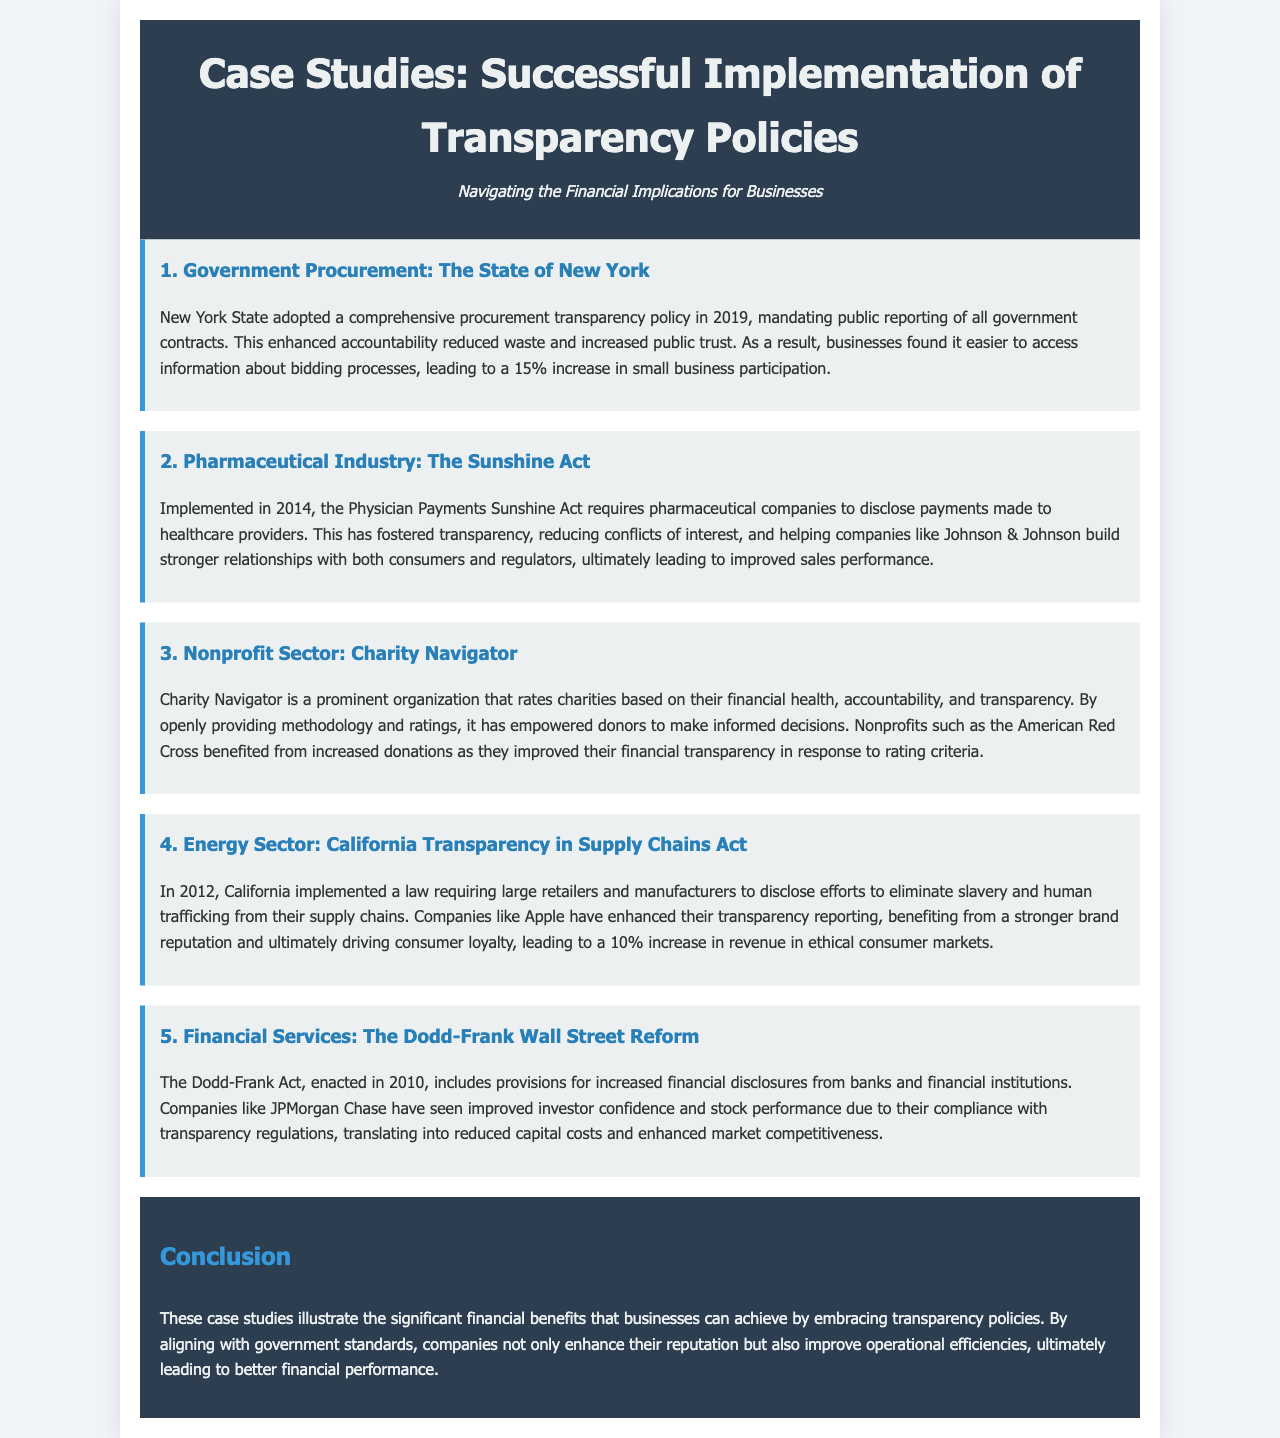What year was the New York State procurement transparency policy adopted? The document states that New York State adopted its comprehensive procurement transparency policy in 2019.
Answer: 2019 What percentage increase did small business participation see after New York's policy implementation? According to the case study, small business participation increased by 15% due to the new procurement transparency policy.
Answer: 15% What act requires pharmaceutical companies to disclose payments to healthcare providers? The document mentions the Physician Payments Sunshine Act implemented in 2014.
Answer: The Sunshine Act Which nonprofit organization rates charities based on accountability and transparency? Charity Navigator is highlighted in the document as the organization that rates charities.
Answer: Charity Navigator What was the financial impact for companies like Apple due to the California Transparency in Supply Chains Act? The case study indicates that companies like Apple experienced a 10% increase in revenue in ethical consumer markets.
Answer: 10% What is a key benefit for businesses embracing transparency policies according to the conclusion? The document states that one key benefit is improved operational efficiencies, leading to better financial performance.
Answer: Improved operational efficiencies What year was the Dodd-Frank Act enacted? The document specifies that the Dodd-Frank Act was enacted in 2010.
Answer: 2010 Which sector benefitted from the increased donations due to improved financial transparency? The nonprofit sector benefited, particularly mentioning organizations like the American Red Cross.
Answer: Nonprofit sector How does transparency impact investor confidence in financial services? According to the document, compliance with transparency regulations has led to improved investor confidence and stock performance for companies like JPMorgan Chase.
Answer: Improved investor confidence 